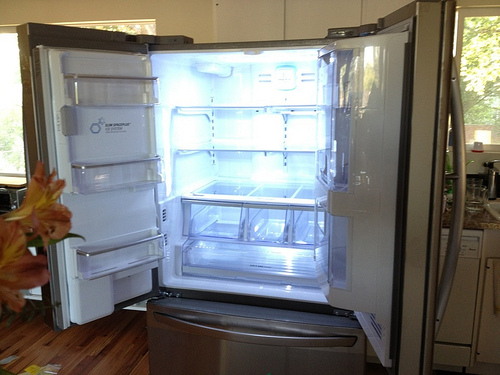Please provide a short description for this region: [0.01, 0.75, 0.3, 0.87]. This section of the image displays the warm wooden floor of the kitchen, with a rich grain texture that contributes to the welcoming ambiance of the space. 